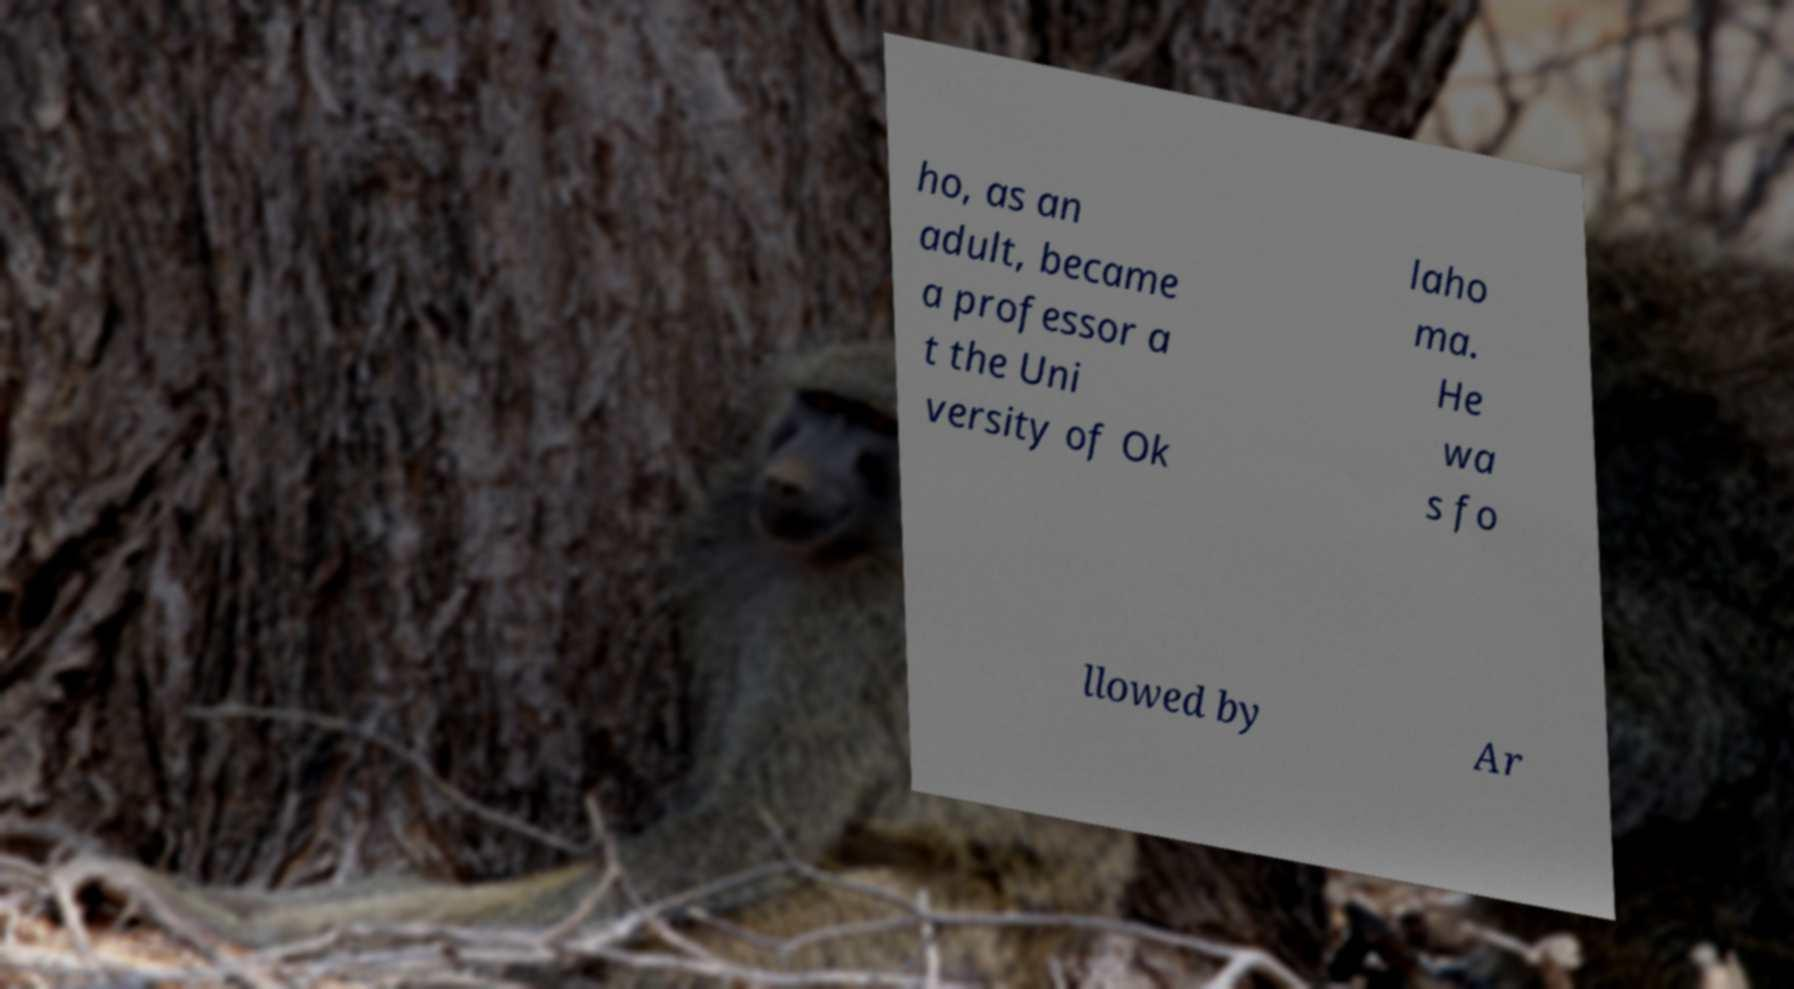There's text embedded in this image that I need extracted. Can you transcribe it verbatim? ho, as an adult, became a professor a t the Uni versity of Ok laho ma. He wa s fo llowed by Ar 